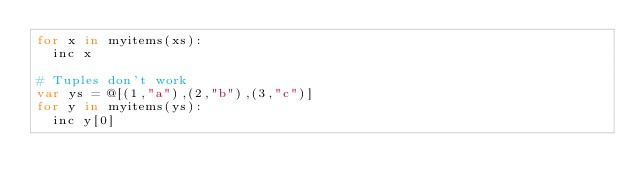<code> <loc_0><loc_0><loc_500><loc_500><_Nim_>for x in myitems(xs):
  inc x

# Tuples don't work
var ys = @[(1,"a"),(2,"b"),(3,"c")]
for y in myitems(ys):
  inc y[0]

</code> 